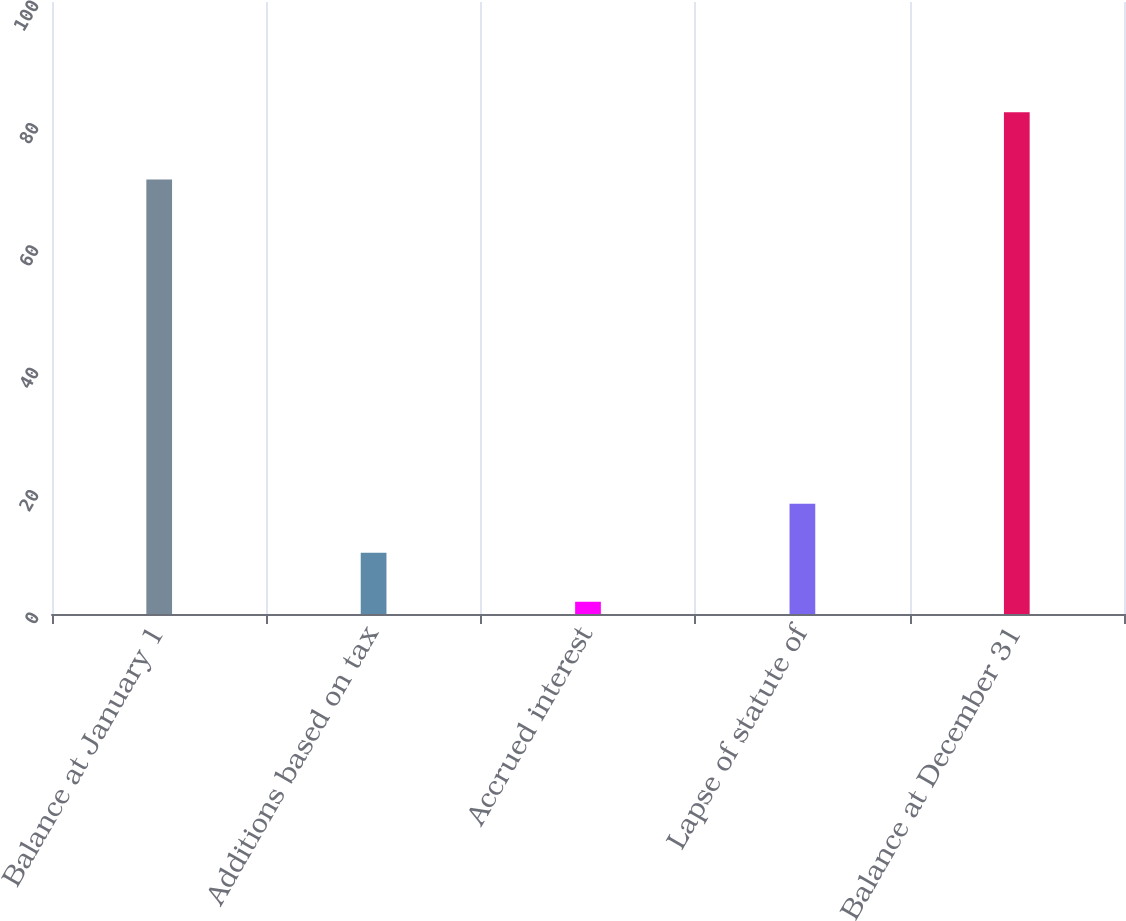Convert chart. <chart><loc_0><loc_0><loc_500><loc_500><bar_chart><fcel>Balance at January 1<fcel>Additions based on tax<fcel>Accrued interest<fcel>Lapse of statute of<fcel>Balance at December 31<nl><fcel>71<fcel>10<fcel>2<fcel>18<fcel>82<nl></chart> 